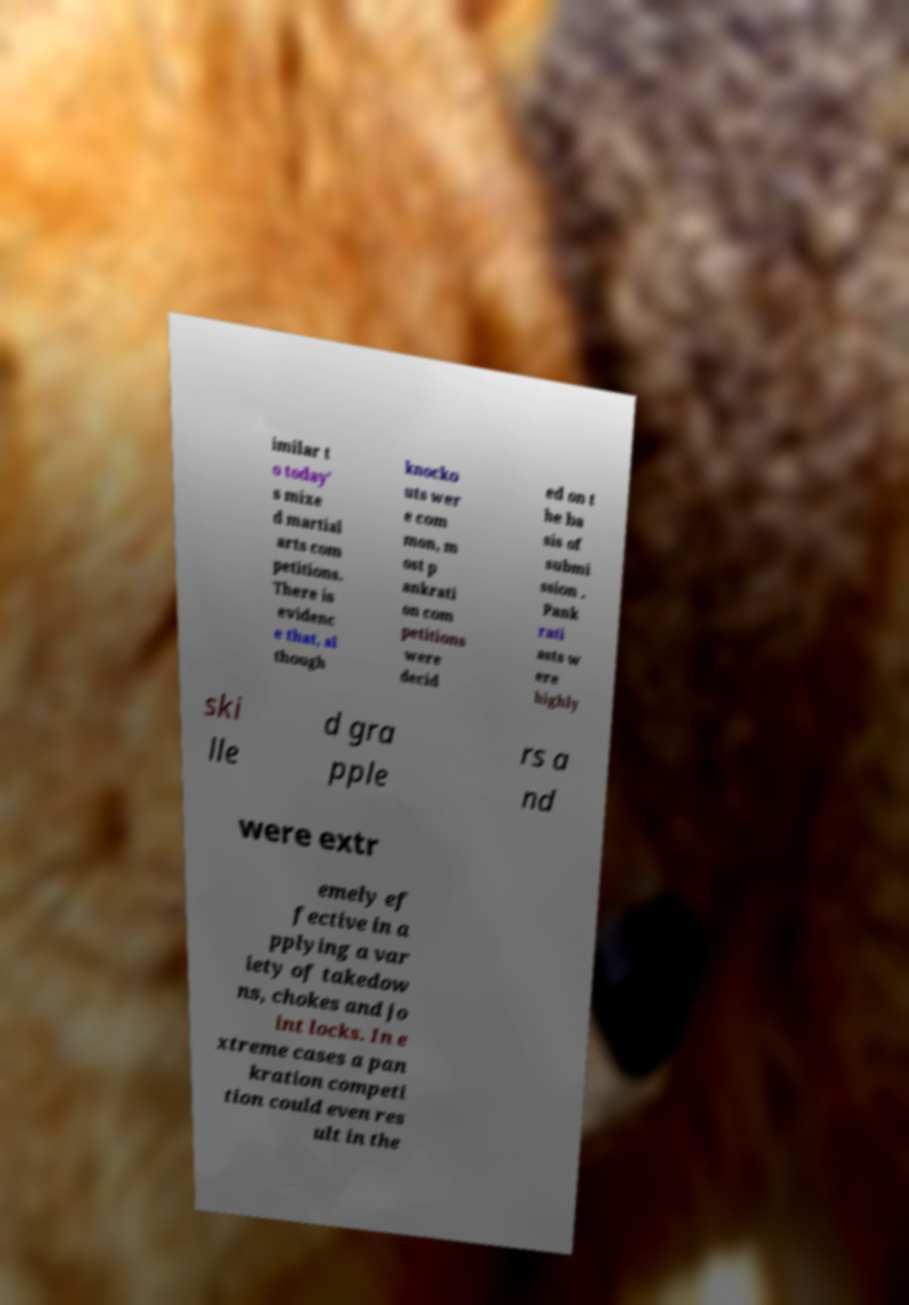Can you accurately transcribe the text from the provided image for me? imilar t o today' s mixe d martial arts com petitions. There is evidenc e that, al though knocko uts wer e com mon, m ost p ankrati on com petitions were decid ed on t he ba sis of submi ssion . Pank rati asts w ere highly ski lle d gra pple rs a nd were extr emely ef fective in a pplying a var iety of takedow ns, chokes and jo int locks. In e xtreme cases a pan kration competi tion could even res ult in the 